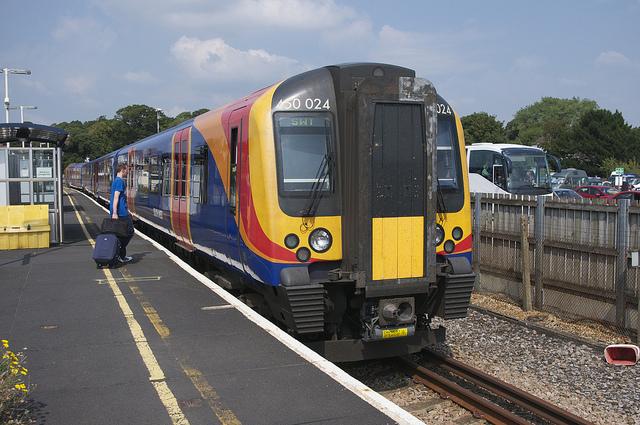What color is the man's shirt?
Short answer required. Blue. How many people are waiting to get on the train?
Keep it brief. 1. Is the train one color?
Answer briefly. No. 